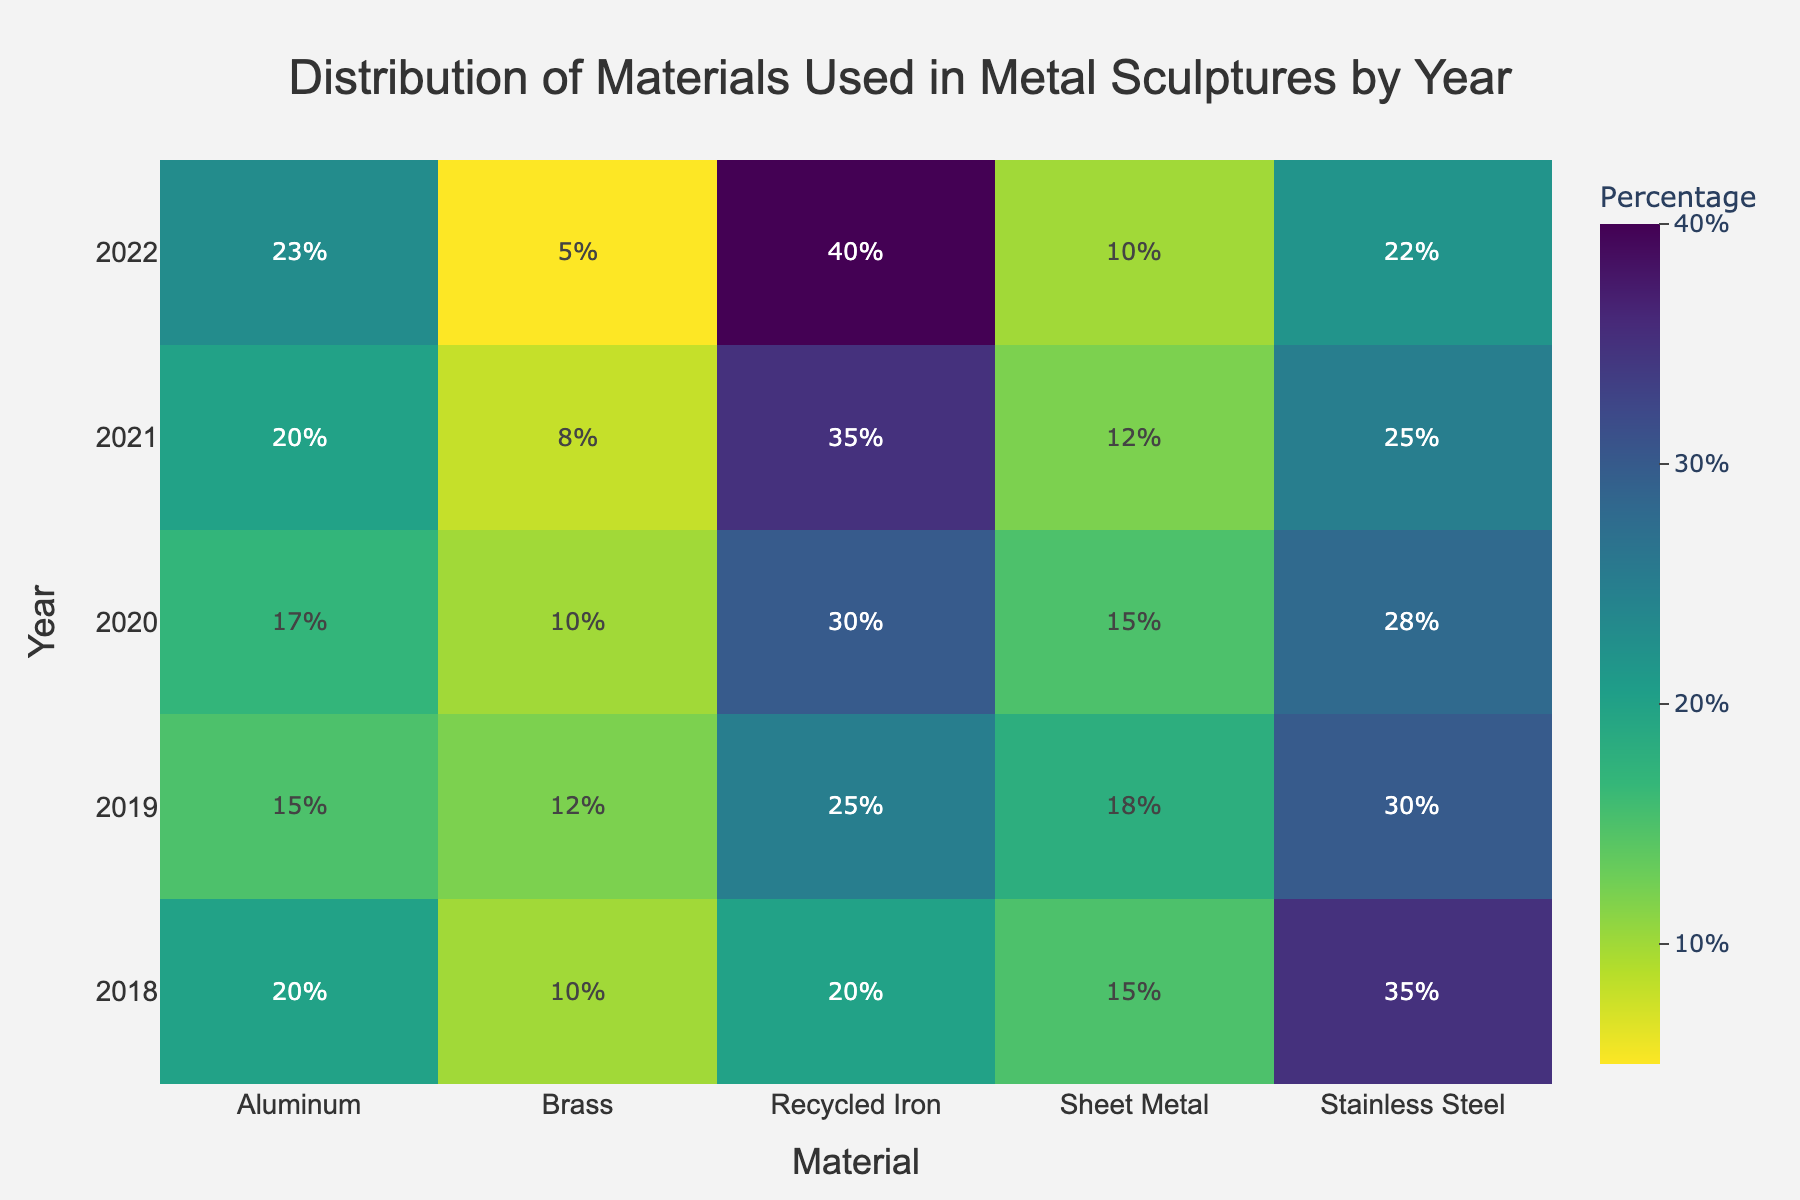What is the most common material used in 2018? The color intensity in the heatmap indicates the percentage of each material used in each year. In 2018, the darkest cell corresponds to Stainless Steel, which has a percentage of 35%.
Answer: Stainless Steel How did the use of Recycled Iron change from 2018 to 2022? By comparing the cells for Recycled Iron across the years from 2018 to 2022, we can see the color becoming more intense. The percentage increased from 20% in 2018 to 40% in 2022.
Answer: Increased Which material had the least usage in 2020? The heatmap shows the percentages of materials by color intensity. Brass has the least intense color in 2020 with a percentage of 10%, which is lower compared to other materials that year.
Answer: Brass What is the total percentage of Aliminum used across all years? We can sum the percentages of Aluminum from each year: 20% (2018) + 15% (2019) + 17% (2020) + 20% (2021) + 23% (2022) = 95%.
Answer: 95% How did the use of Sheet Metal change over the years? Examining the color intensity for Sheet Metal from 2018 to 2022, we see that the percentage started at 15% in 2018, fluctuated slightly and then decreased to 10% in 2022.
Answer: Decreased Which year had the highest use of Recycled Iron? The color intensity for Recycled Iron is most intense in the year 2022, indicating the highest percentage at 40%.
Answer: 2022 In which year was the use of Stainless Steel the lowest? Looking at the color intensity for Stainless Steel across the years, the least intense color corresponds to 2022, with a percentage of 22%.
Answer: 2022 Compare the use of Brass and Aluminum in 2021. Which one was used more? By comparing the color intensities for Brass and Aluminum in 2021, Aluminum has a darker color representing a higher percentage at 20%, compared to Brass at 8%.
Answer: Aluminum Which material's usage has constantly increased every year? Observing the color gradients for each material over the years, Recycled Iron shows a consistent increase in percentage every year from 2018 (20%) to 2022 (40%).
Answer: Recycled Iron What was the average percentage use of Sheet Metal over the given years? To find the average: (15% (2018) + 18% (2019) + 15% (2020) + 12% (2021) + 10% (2022)) / 5 = 14%.
Answer: 14% 